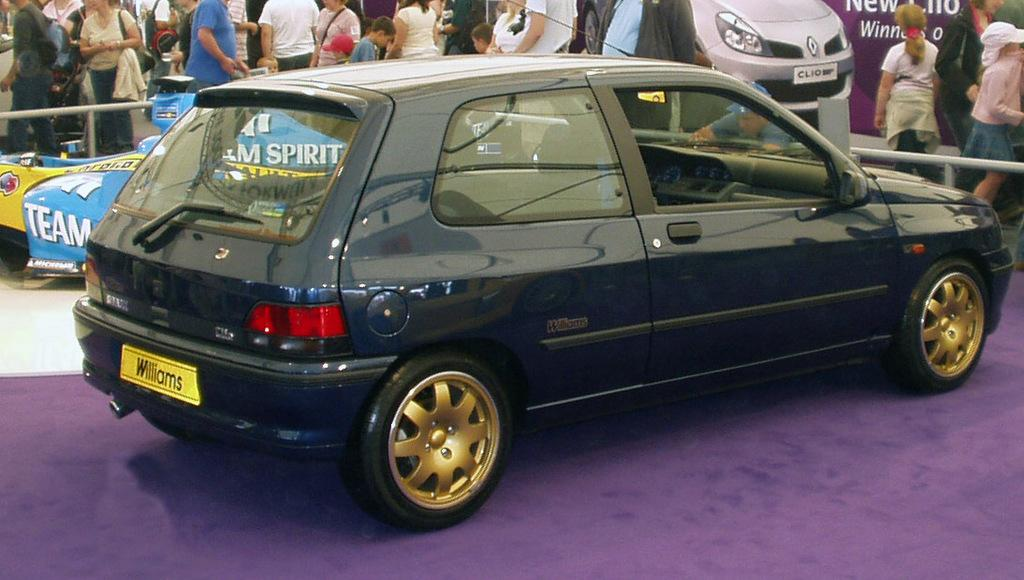What object is placed on the floor in the image? There is a car on the floor in the image. What can be seen in the background of the image? There is a group of people standing and a fence in the background of the image. Are there any additional elements in the background of the image? Yes, there are banners in the background of the image. What type of toothpaste is being advertised on the banners in the image? There is no toothpaste or advertisement present in the image; the banners are not specified to be promoting any product. Who is the queen standing with the group of people in the background of the image? There is no mention of a queen or any specific individuals in the group of people in the image. 